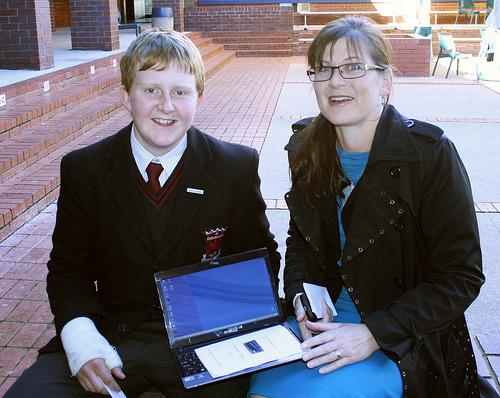Question: what color jacket are both people wearing?
Choices:
A. Black.
B. Blue.
C. Red.
D. White.
Answer with the letter. Answer: A Question: how many people are shown?
Choices:
A. Three.
B. Four.
C. Five.
D. Two.
Answer with the letter. Answer: D Question: what color dress is the girl wearing?
Choices:
A. Yellow.
B. Red.
C. Blue.
D. White.
Answer with the letter. Answer: C Question: where was the photo taken?
Choices:
A. Near the door.
B. Near stairs.
C. Near the steps.
D. Near the Rock wall.
Answer with the letter. Answer: B 